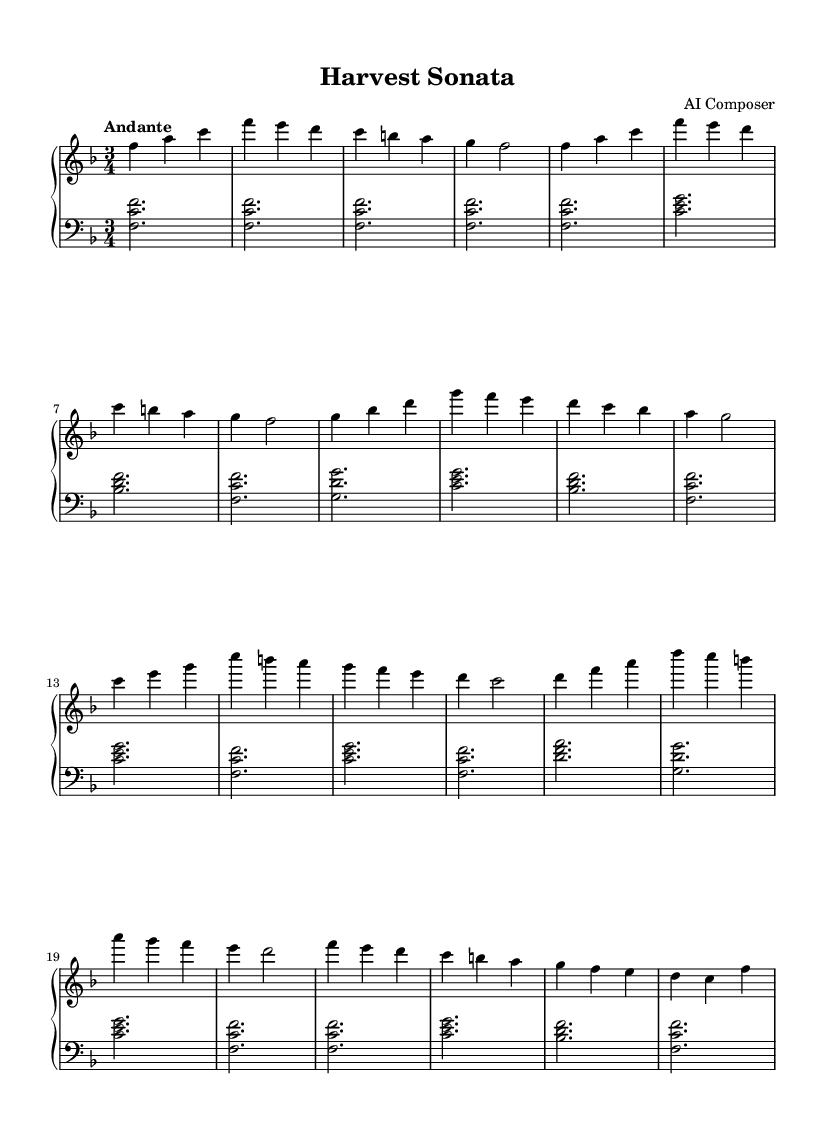What is the key signature of this music? The key signature is F major, which contains one flat (B flat). This can be determined by looking at the key signature symbol at the beginning of the staff.
Answer: F major What is the time signature of this music? The time signature is 3/4, indicated at the beginning of the score. It shows that there are three beats per measure and the quarter note gets one beat.
Answer: 3/4 What is the indicated tempo of this piece? The indicated tempo is "Andante," which commonly refers to a moderately slow pace in music. This is stated above the staff at the beginning of the piece.
Answer: Andante How many themes are present in this music? There are two distinct themes present in this piece: Theme A and Theme B. This is evident from the separate sections labeled as Theme A and Theme B in the score.
Answer: 2 Which theme has the notes that start with C, E, and G? The notes that start with C, E, and G belong to Theme B. By analyzing the note sequence, we see that C, E, and G appear in one of the initial measures of Theme B.
Answer: Theme B What is the interval of the first harmony in the left hand? The first harmony in the left hand features a perfect octave with F and C. This is deduced by recognizing the distance between the two notes F and C played concurrently at the beginning of the piece.
Answer: Perfect octave What is the structure designation of the final section of the piece? The final section of the piece is designated as a Coda. This is explicitly mentioned in the score as the last part, distinguishing it from the main themes presented earlier.
Answer: Coda 